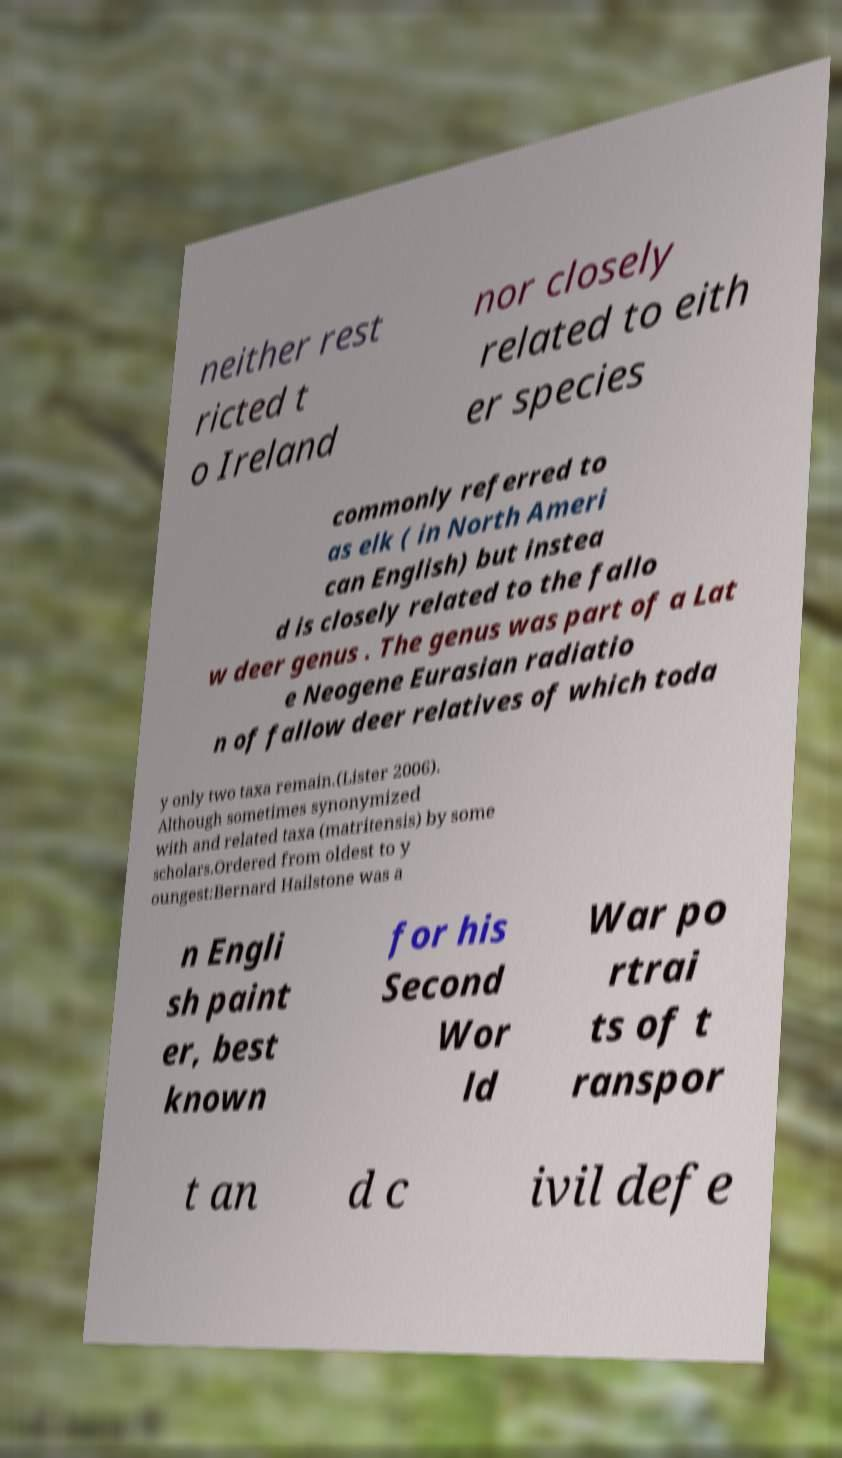There's text embedded in this image that I need extracted. Can you transcribe it verbatim? neither rest ricted t o Ireland nor closely related to eith er species commonly referred to as elk ( in North Ameri can English) but instea d is closely related to the fallo w deer genus . The genus was part of a Lat e Neogene Eurasian radiatio n of fallow deer relatives of which toda y only two taxa remain.(Lister 2006). Although sometimes synonymized with and related taxa (matritensis) by some scholars.Ordered from oldest to y oungest:Bernard Hailstone was a n Engli sh paint er, best known for his Second Wor ld War po rtrai ts of t ranspor t an d c ivil defe 